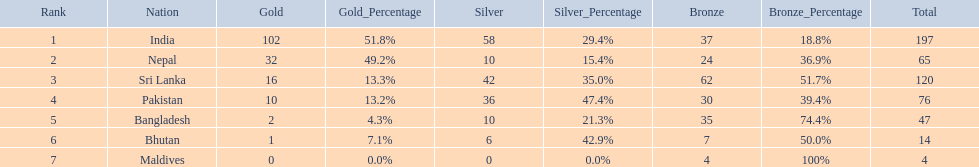How many gold medals were won by the teams? 102, 32, 16, 10, 2, 1, 0. What country won no gold medals? Maldives. 